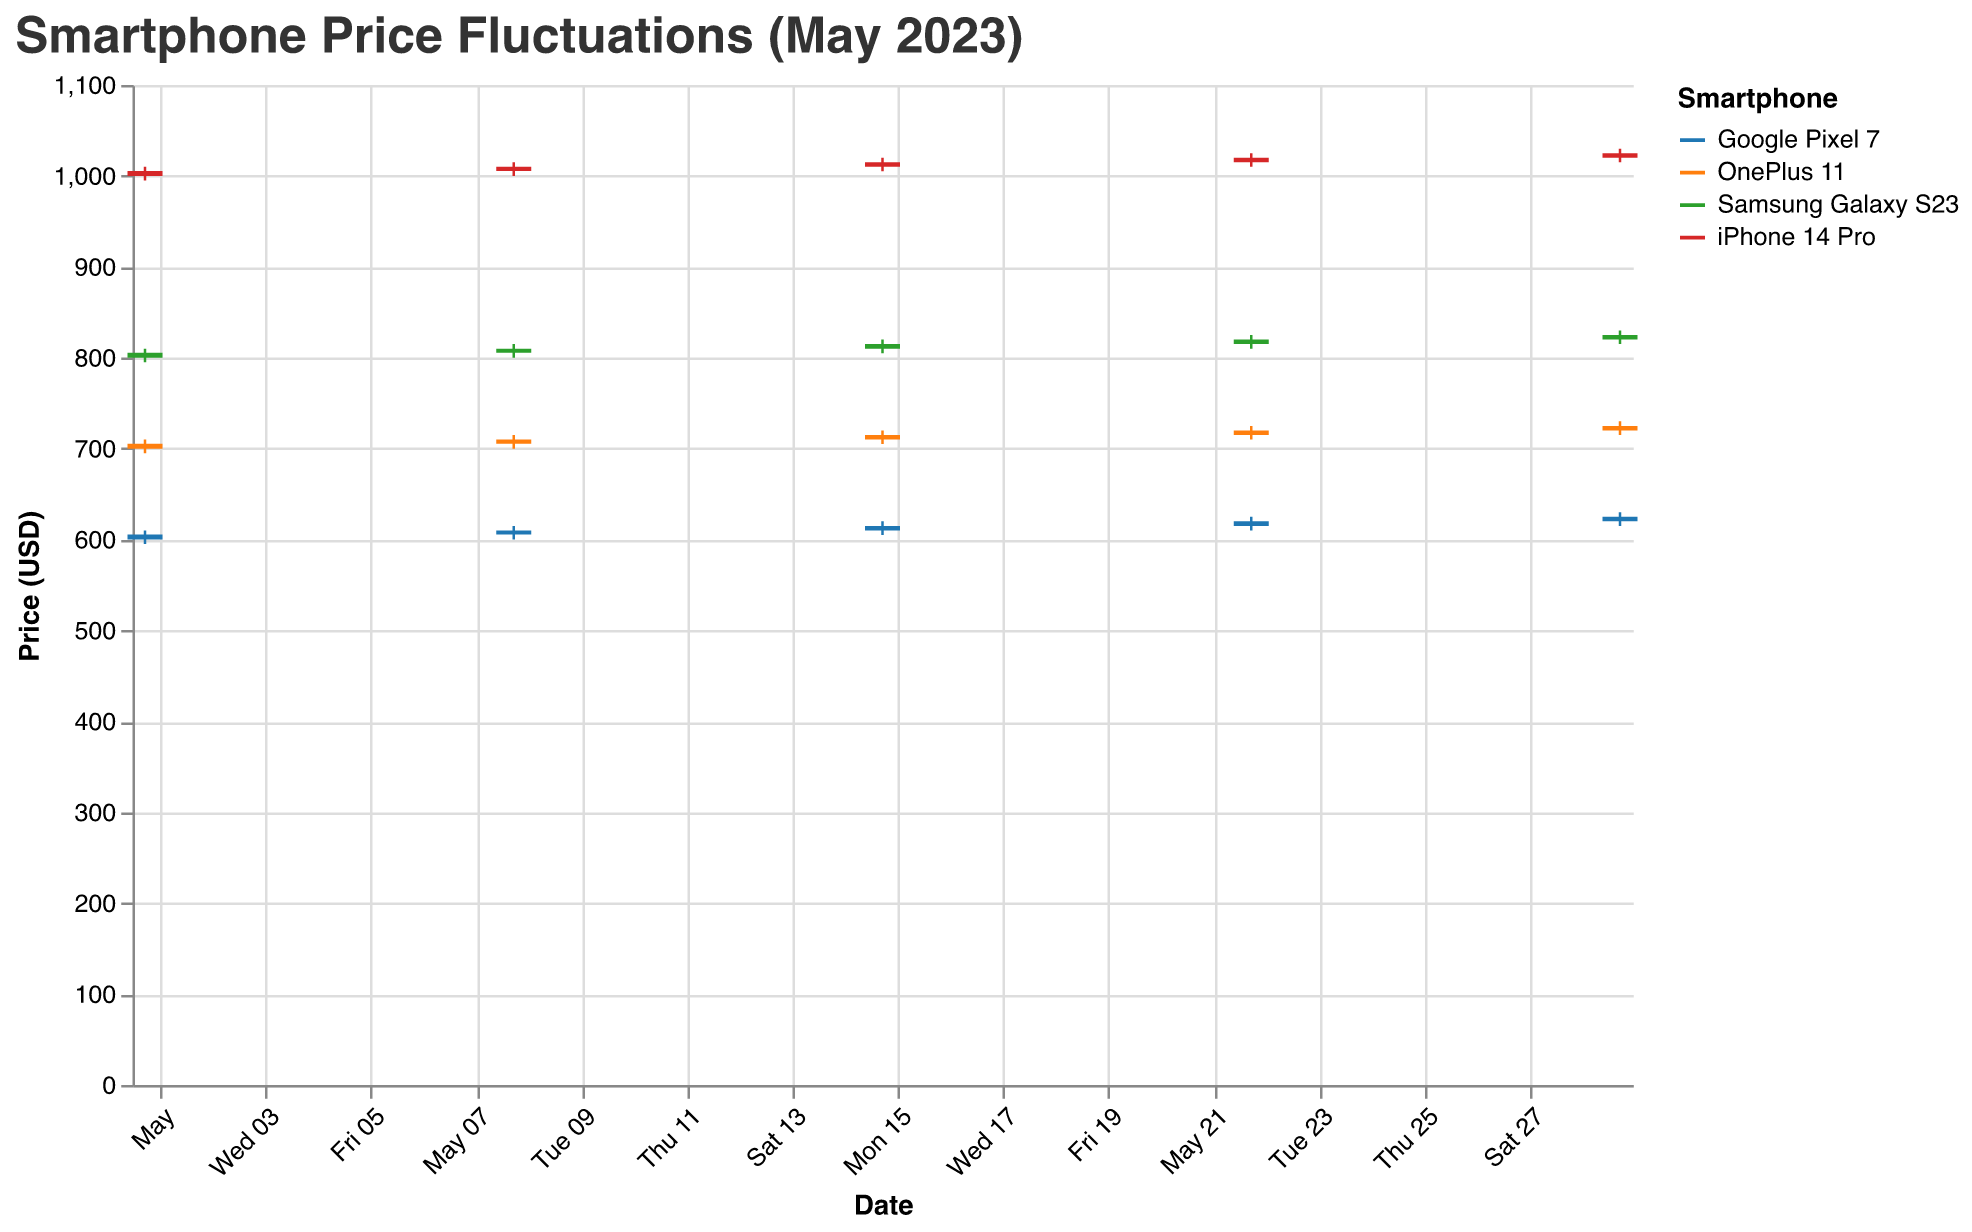How many smartphones are charted in this figure? Count the different smartphone models listed in the chart: iPhone 14 Pro, Samsung Galaxy S23, Google Pixel 7, and OnePlus 11.
Answer: 4 Which smartphone had the highest closing price on May 29, 2023? Look at the closing prices on May 29 for all smartphones. The highest closing price is for the iPhone 14 Pro.
Answer: iPhone 14 Pro What's the average opening price of the Samsung Galaxy S23 throughout May 2023? Sum the opening prices of the Samsung Galaxy S23 on all dates provided (799.99, 805.50, 810.00, 815.00, 820.00) and divide by the number of data points (5). (799.99 + 805.50 + 810.00 + 815.00 + 820.00) / 5 = 4100.49 / 5 = 820.098
Answer: 810.10 On which date did the Google Pixel 7 have the smallest price fluctuation? Calculate the price fluctuation for each date, which is the difference between the High and Low prices. The smallest fluctuation is on May 15 (High: 620.00, Low: 605.00, Fluctuation: 620.00 - 605.00 = 15.00).
Answer: May 15, 2023 Which smartphone had the highest price fluctuation on May 1, 2023? Compare the High and Low prices for each smartphone on May 1, 2023. The highest fluctuation is for the iPhone 14 Pro (High: 1009.99, Low: 995.00, Fluctuation: 1009.99 - 995.00 = 14.99).
Answer: iPhone 14 Pro Did any smartphone have an increasing closing price every week in May 2023? Check the closing prices each week for every smartphone. The iPhone 14 Pro has a consistent increase each week: 1005.50, 1010.00, 1015.00, 1020.00, 1025.00.
Answer: Yes, iPhone 14 Pro What's the difference between the highest close prices of iPhone 14 Pro and Google Pixel 7 in May 2023? The highest close price for the iPhone 14 Pro is 1025.00, and for Google Pixel 7, it is 625.00. The difference is 1025.00 - 625.00 = 400.00.
Answer: 400.00 Which smartphone had the lowest opening price on May 22, 2023? Refer to the opening prices for all smartphones on May 22, 2023. The Google Pixel 7 has the lowest opening price at 615.00.
Answer: Google Pixel 7 Did the OnePlus 11's price fluctuate more or less than the Samsung Galaxy S23 on May 15, 2023? Compare the price fluctuations (High - Low) for both smartphones on that date. OnePlus 11: 720.00 - 705.00 = 15.00, Samsung Galaxy S23: 820.00 - 805.00 = 15.00. They have the same fluctuation.
Answer: Equal What's the percentage increase in the closing price of the OnePlus 11 from May 1 to May 29, 2023? Calculate the difference in closing prices from May 1 (705.50) to May 29 (725.00) and divide by the May 1 closing price, then multiply by 100 to get the percentage. ((725.00 - 705.50) / 705.50) * 100 = 2.76%
Answer: 2.76% 